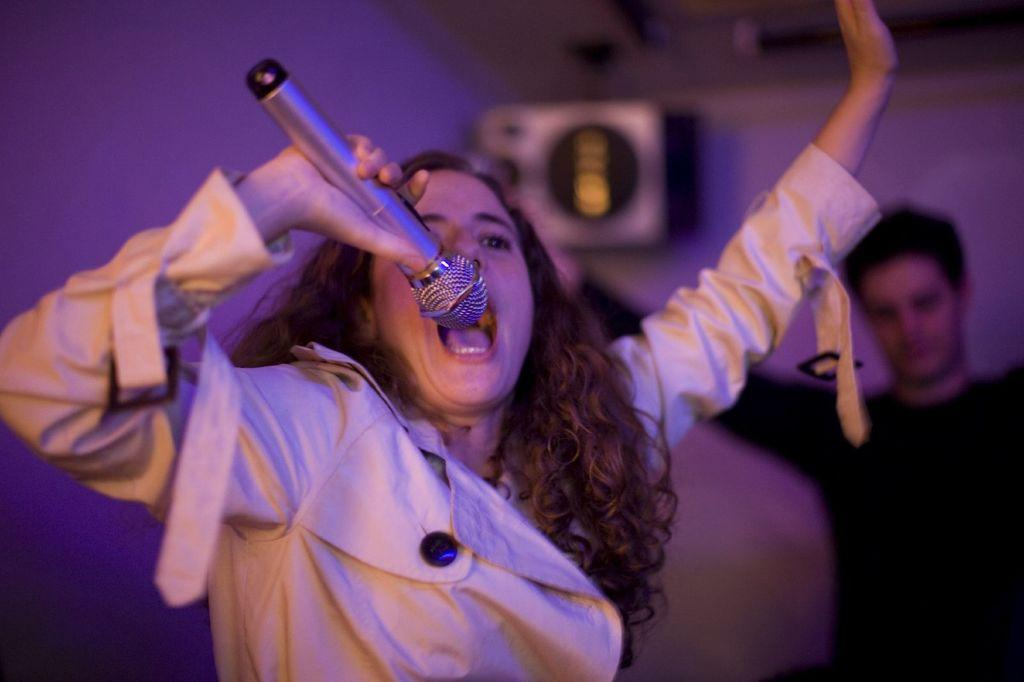What is the person in the image doing? The person is standing and singing. What is the person holding while singing? The person is holding a microphone in her hand. Can you describe the other person in the image? There is another person standing at the back, wearing a black t-shirt. What type of silk is being used to create the yoke of the person's outfit in the image? There is no yoke or silk mentioned in the image; the person is wearing a microphone while singing. 